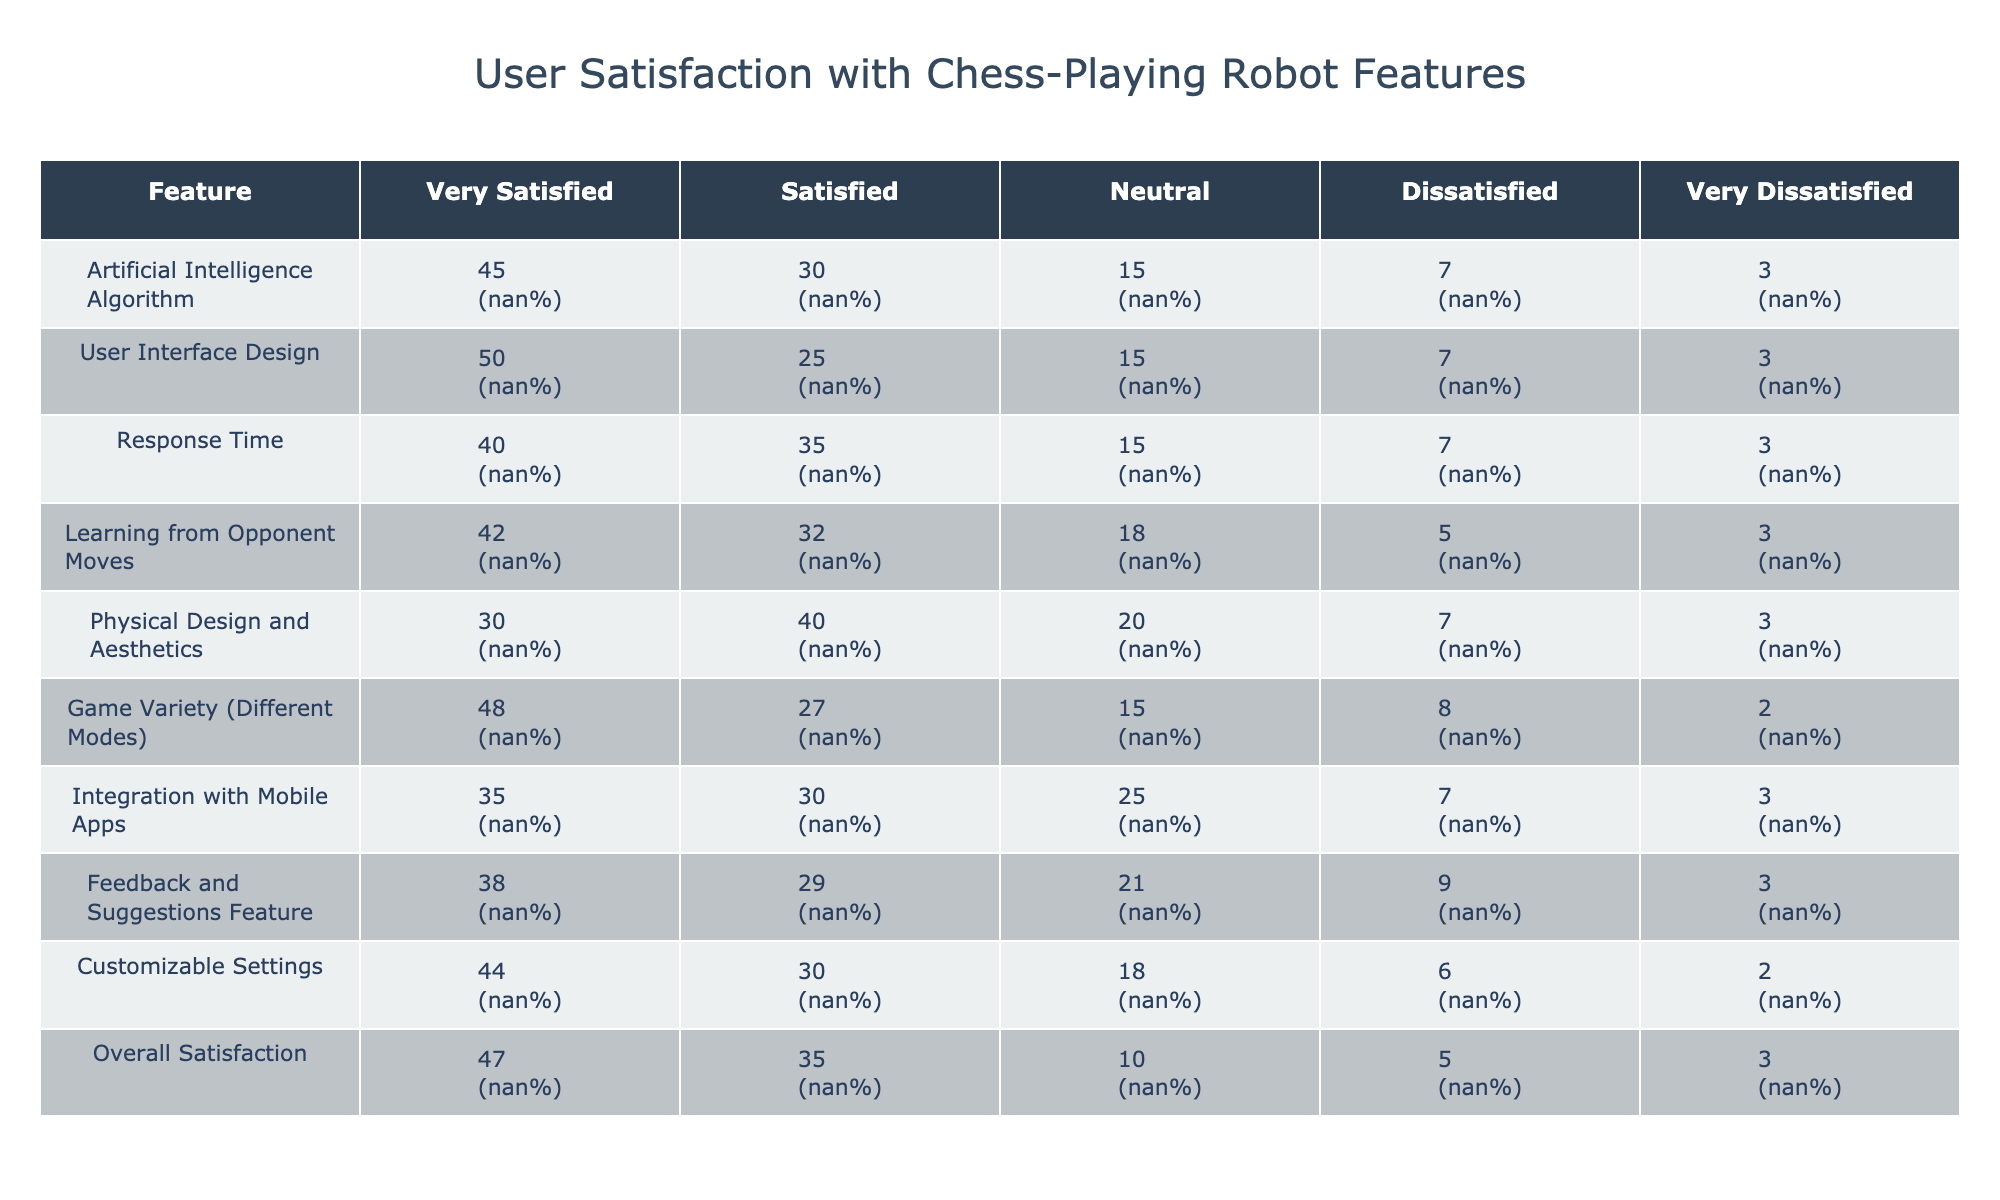What feature received the highest percentage of "Very Satisfied" responses? The "User Interface Design" feature received 50 respondents who were "Very Satisfied," which is the highest percentage compared to other features.
Answer: User Interface Design What is the percentage of respondents who are "Dissatisfied" with the "Learning from Opponent Moves" feature? There were 5 respondents who were "Dissatisfied" with this feature. To find the percentage, we calculate (5/100) * 100 = 5%.
Answer: 5% Which feature has the lowest total count of "Very Satisfied" and "Satisfied" combined? For "Physical Design and Aesthetics," there are 30 "Very Satisfied" and 40 "Satisfied" respondents combined, which is 70. Comparing it to all other features reveals that it has the lowest combined total.
Answer: Physical Design and Aesthetics Is there a feature where the combined "Neutral," "Dissatisfied," and "Very Dissatisfied" percentages exceed 50%? To determine this, we add the percentages of "Neutral" (15%), "Dissatisfied" (7%), and "Very Dissatisfied" (3%) for all features. The "Integration with Mobile Apps" feature has a total of 25% for these categories, which does not exceed 50%. Therefore, the answer is no.
Answer: No What is the average percentage of respondents who are "Satisfied" across all features? First, we sum the "Satisfied" counts: (30 + 25 + 35 + 32 + 40 + 27 + 30 + 29 + 30 + 35) =  309. Then, we divide it by the number of features (10): 309/100 = 3.09 or 30.9%.
Answer: 30.9% 